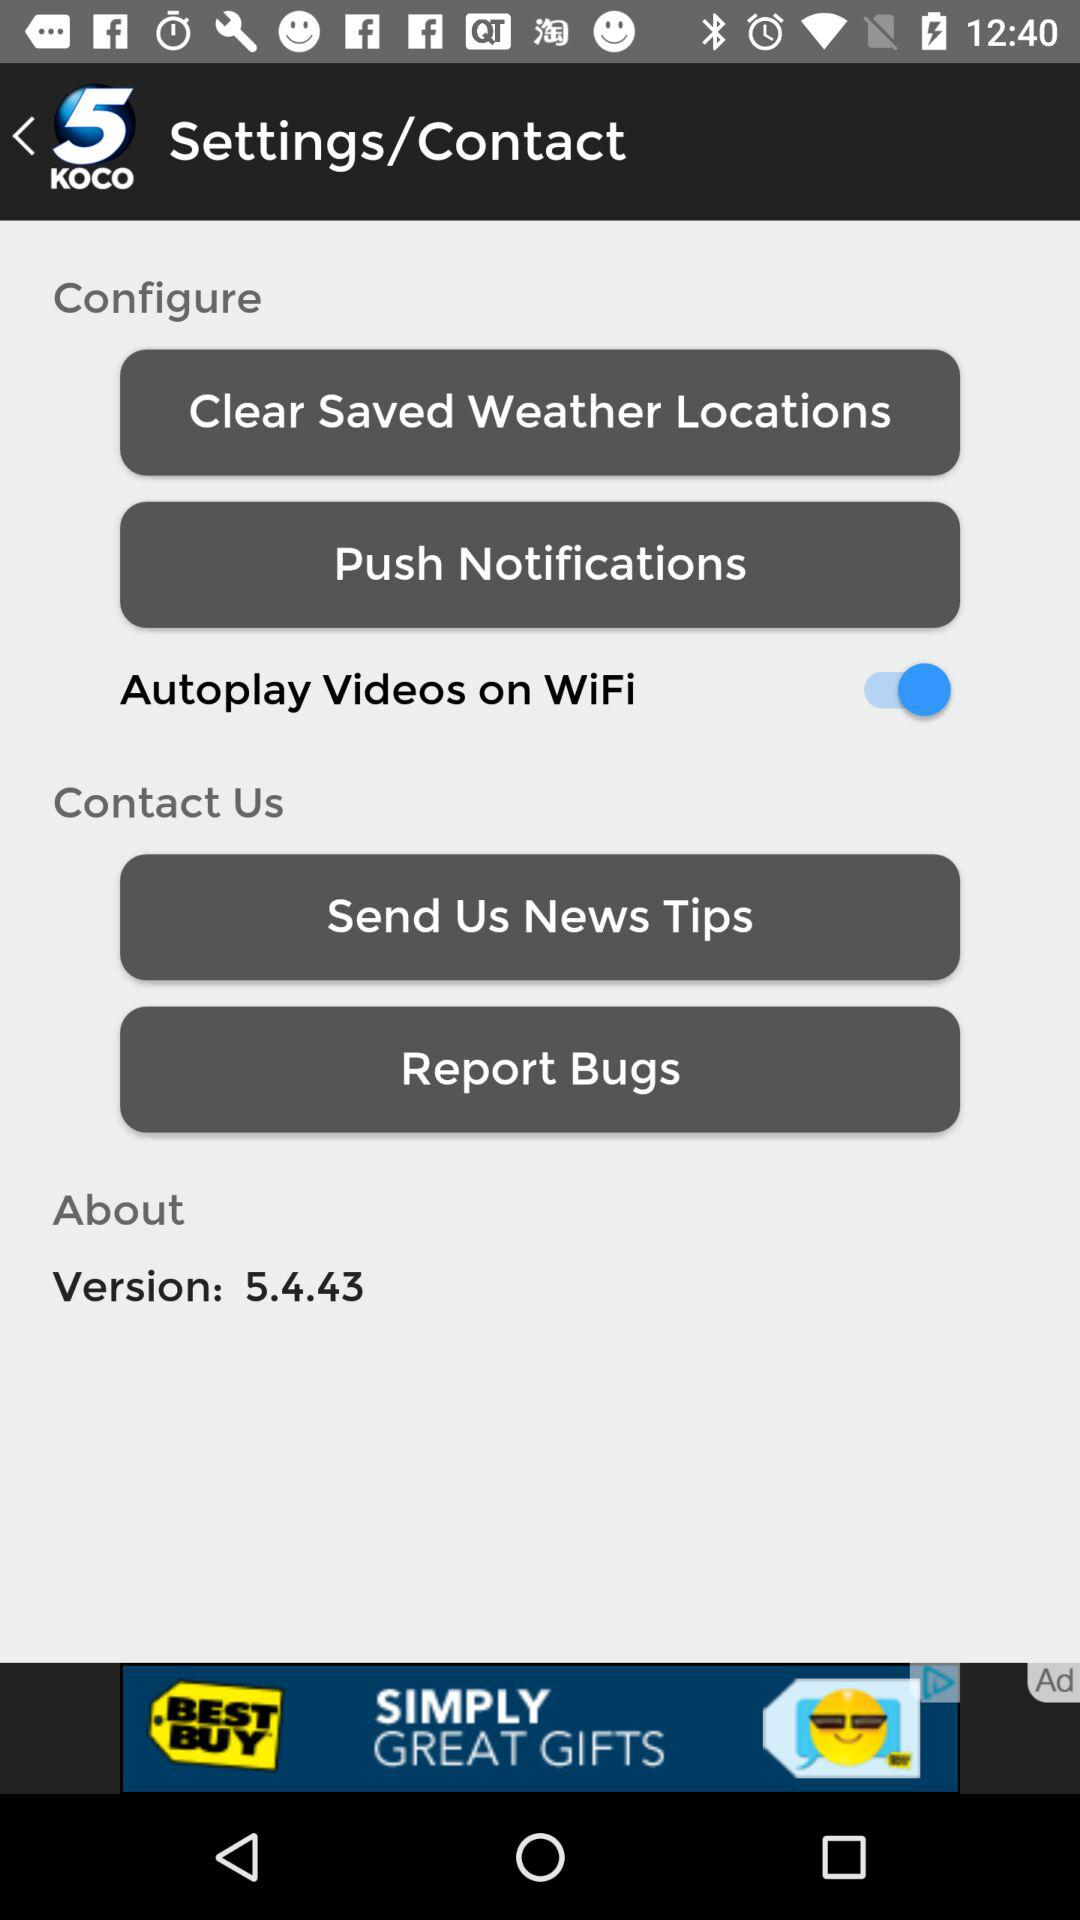What's the version? The version is 5.4.43. 